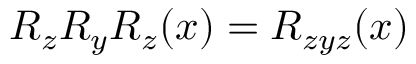Convert formula to latex. <formula><loc_0><loc_0><loc_500><loc_500>R _ { z } R _ { y } R _ { z } ( x ) = R _ { z y z } ( x )</formula> 